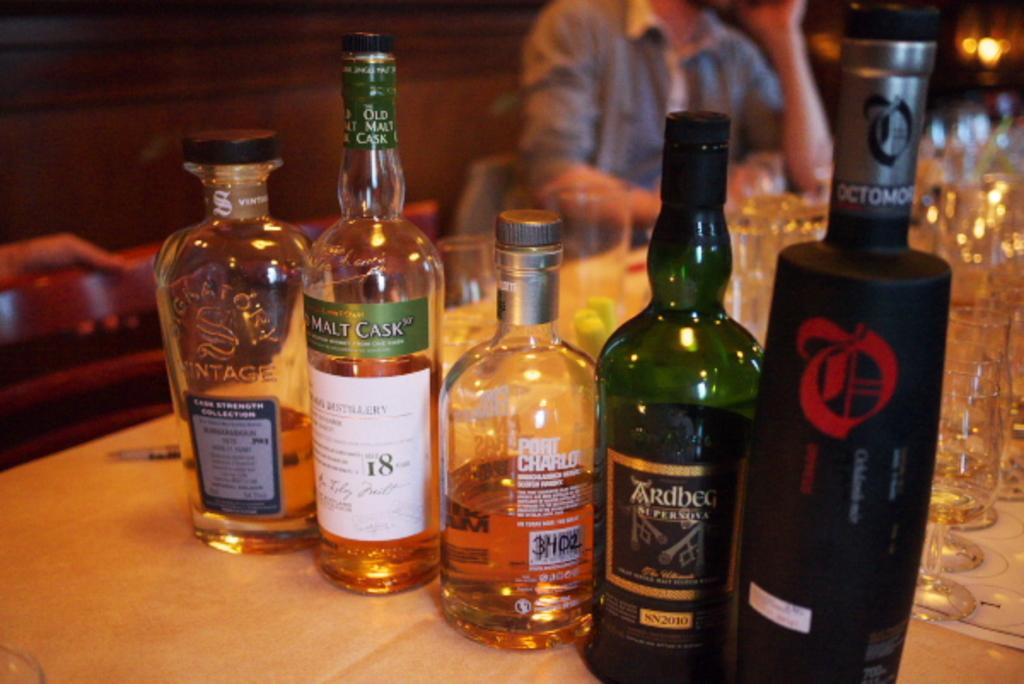What numbers are written on the middle bottle?
Your response must be concise. 3402. 